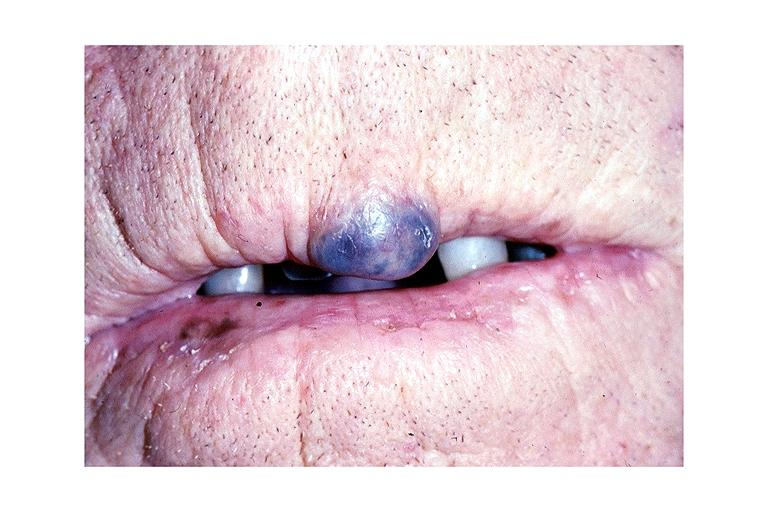does this image show hemangioma?
Answer the question using a single word or phrase. Yes 